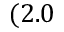Convert formula to latex. <formula><loc_0><loc_0><loc_500><loc_500>( 2 . 0</formula> 